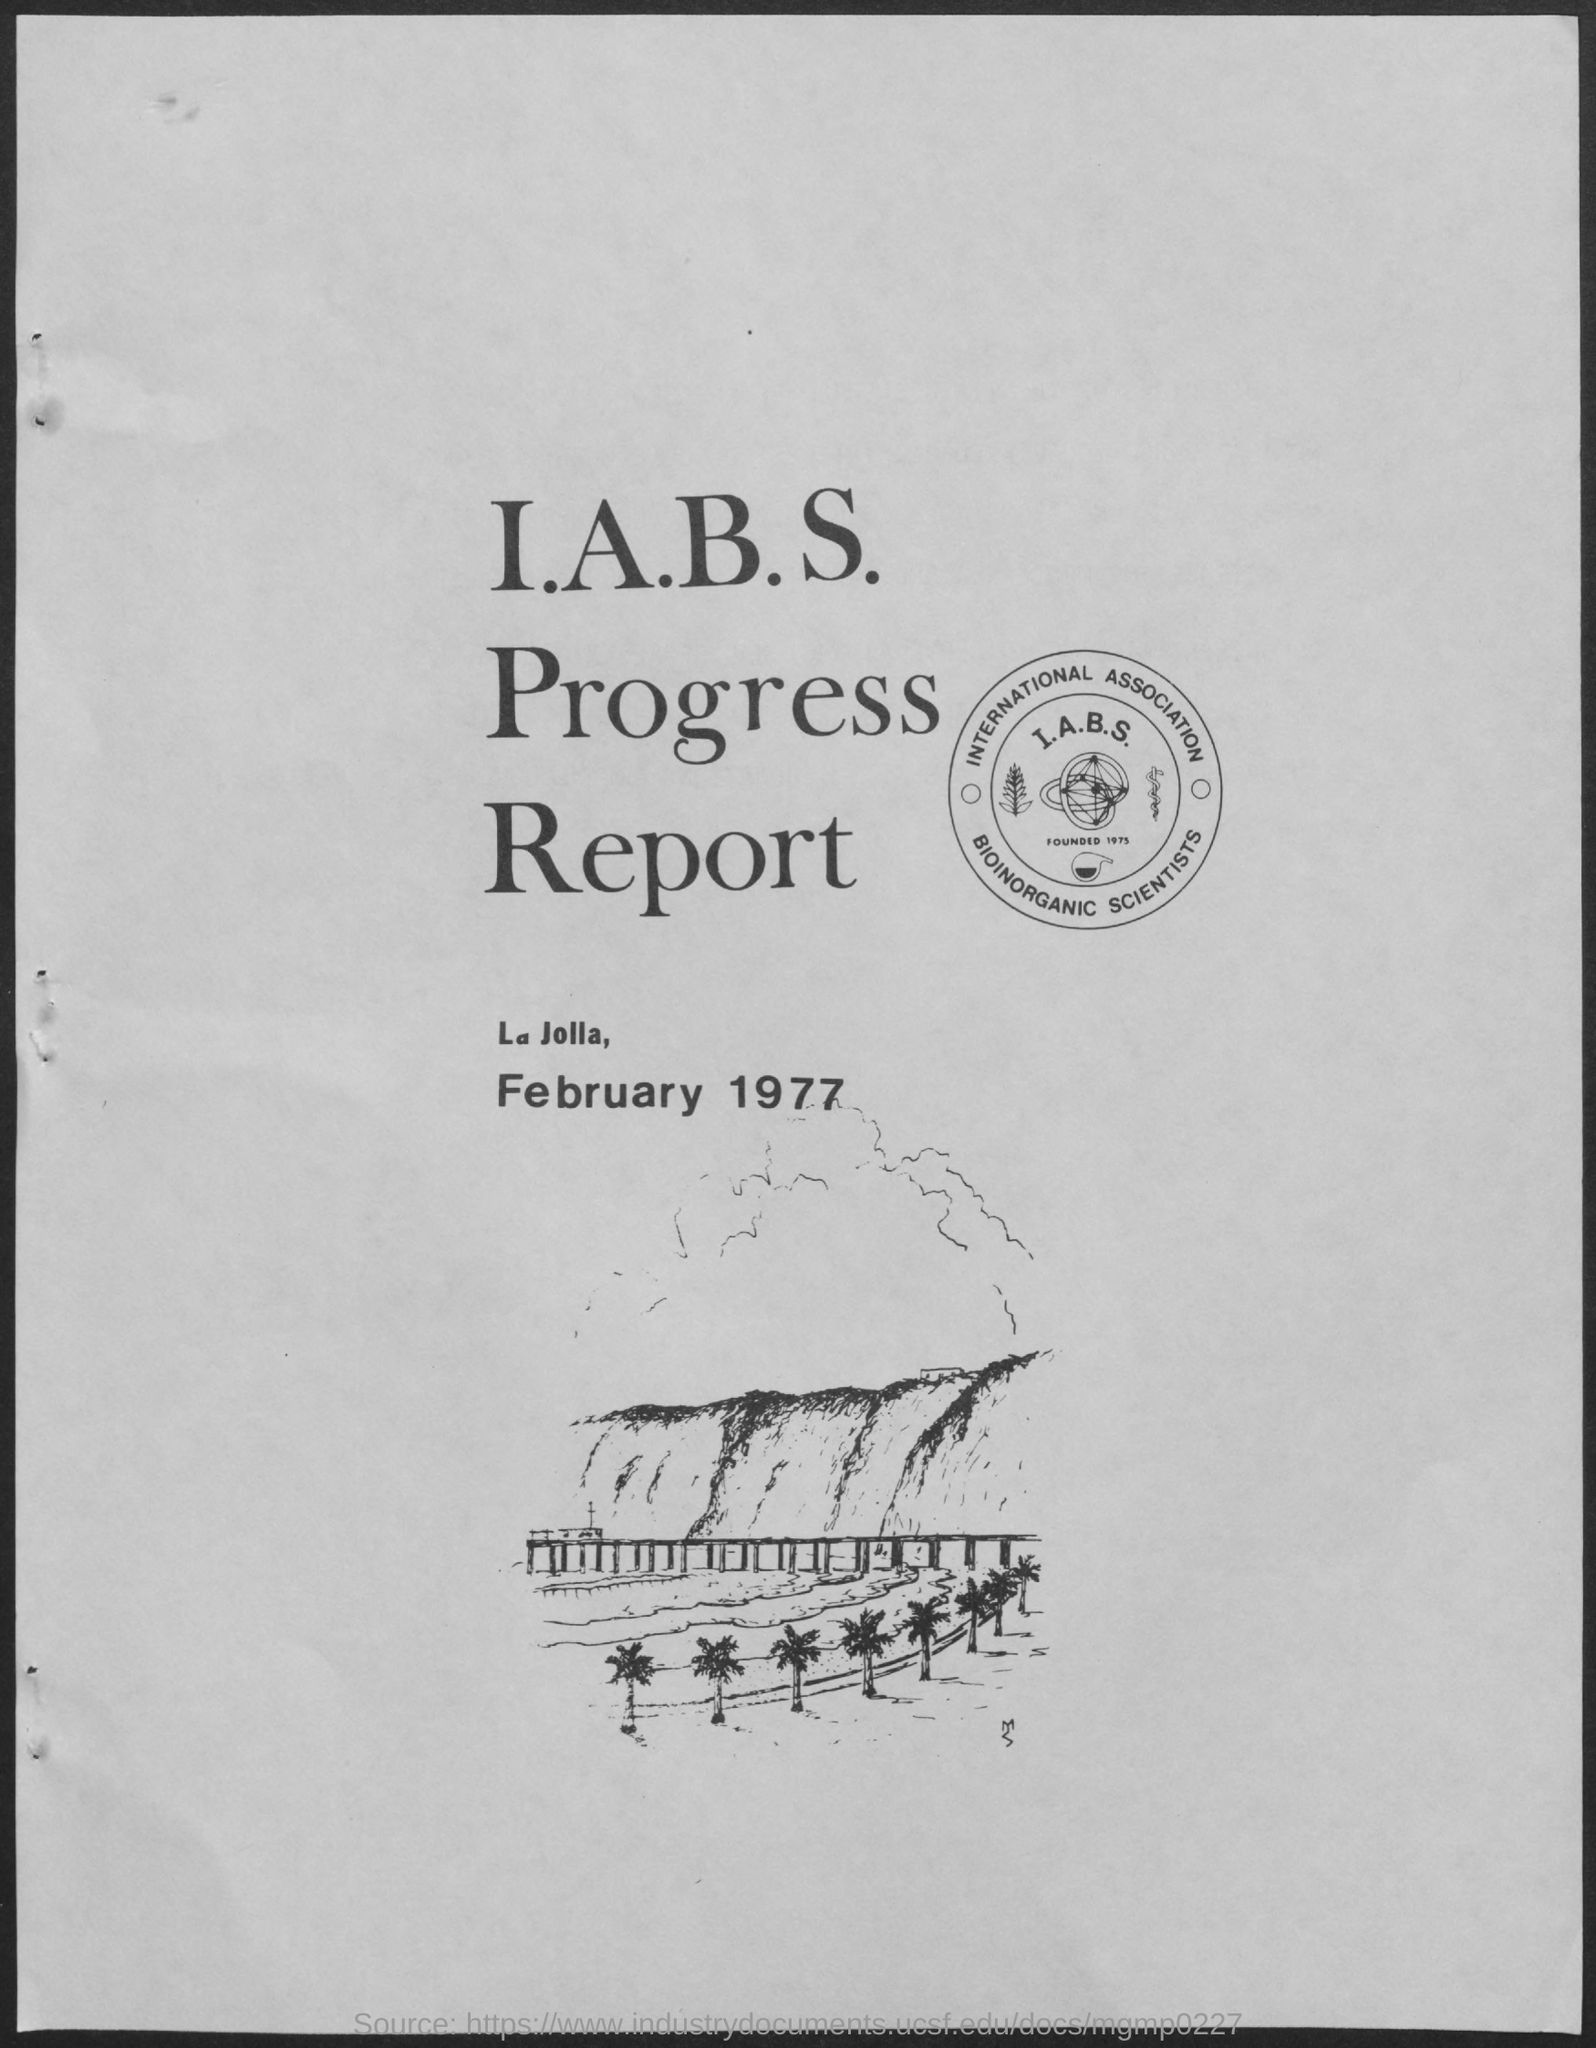Draw attention to some important aspects in this diagram. The title of the document is the I.A.B.S. Progress Report. The document mentions that the date is February 1977. 